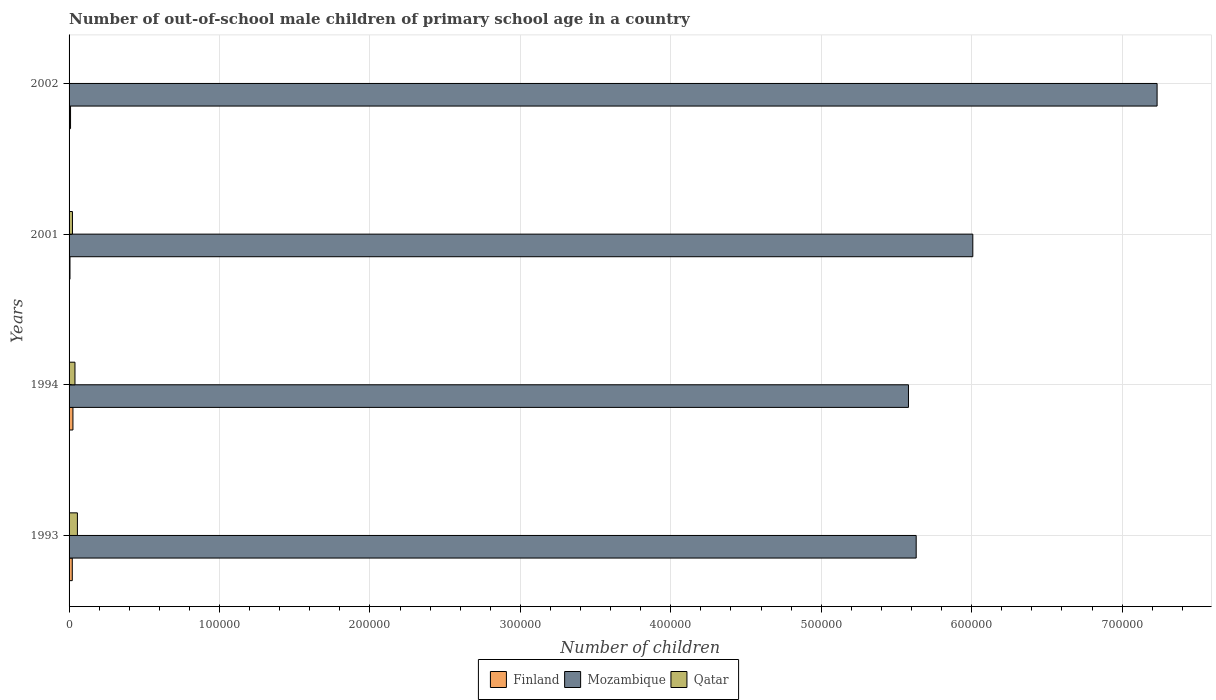Are the number of bars per tick equal to the number of legend labels?
Provide a succinct answer. Yes. Are the number of bars on each tick of the Y-axis equal?
Make the answer very short. Yes. How many bars are there on the 3rd tick from the bottom?
Offer a very short reply. 3. What is the label of the 3rd group of bars from the top?
Make the answer very short. 1994. In how many cases, is the number of bars for a given year not equal to the number of legend labels?
Offer a terse response. 0. What is the number of out-of-school male children in Mozambique in 1994?
Make the answer very short. 5.58e+05. Across all years, what is the maximum number of out-of-school male children in Mozambique?
Your response must be concise. 7.23e+05. Across all years, what is the minimum number of out-of-school male children in Finland?
Your answer should be compact. 611. In which year was the number of out-of-school male children in Finland minimum?
Your answer should be very brief. 2001. What is the total number of out-of-school male children in Mozambique in the graph?
Your response must be concise. 2.45e+06. What is the difference between the number of out-of-school male children in Qatar in 1994 and that in 2001?
Provide a short and direct response. 1671. What is the difference between the number of out-of-school male children in Mozambique in 1994 and the number of out-of-school male children in Finland in 1993?
Offer a very short reply. 5.56e+05. What is the average number of out-of-school male children in Mozambique per year?
Keep it short and to the point. 6.11e+05. In the year 2001, what is the difference between the number of out-of-school male children in Finland and number of out-of-school male children in Mozambique?
Your response must be concise. -6.00e+05. What is the ratio of the number of out-of-school male children in Mozambique in 1994 to that in 2002?
Provide a short and direct response. 0.77. What is the difference between the highest and the second highest number of out-of-school male children in Qatar?
Offer a terse response. 1618. What is the difference between the highest and the lowest number of out-of-school male children in Qatar?
Offer a very short reply. 5384. What does the 3rd bar from the top in 1994 represents?
Ensure brevity in your answer.  Finland. What does the 3rd bar from the bottom in 1993 represents?
Make the answer very short. Qatar. Is it the case that in every year, the sum of the number of out-of-school male children in Qatar and number of out-of-school male children in Mozambique is greater than the number of out-of-school male children in Finland?
Provide a short and direct response. Yes. How many bars are there?
Your answer should be very brief. 12. How many years are there in the graph?
Provide a short and direct response. 4. What is the difference between two consecutive major ticks on the X-axis?
Your answer should be compact. 1.00e+05. Does the graph contain grids?
Make the answer very short. Yes. Where does the legend appear in the graph?
Provide a short and direct response. Bottom center. What is the title of the graph?
Offer a very short reply. Number of out-of-school male children of primary school age in a country. Does "Kosovo" appear as one of the legend labels in the graph?
Offer a terse response. No. What is the label or title of the X-axis?
Your answer should be very brief. Number of children. What is the Number of children of Finland in 1993?
Offer a very short reply. 2135. What is the Number of children in Mozambique in 1993?
Provide a short and direct response. 5.63e+05. What is the Number of children of Qatar in 1993?
Provide a succinct answer. 5541. What is the Number of children in Finland in 1994?
Make the answer very short. 2569. What is the Number of children of Mozambique in 1994?
Your response must be concise. 5.58e+05. What is the Number of children of Qatar in 1994?
Your answer should be compact. 3923. What is the Number of children in Finland in 2001?
Keep it short and to the point. 611. What is the Number of children in Mozambique in 2001?
Your answer should be very brief. 6.01e+05. What is the Number of children of Qatar in 2001?
Your answer should be compact. 2252. What is the Number of children of Finland in 2002?
Your response must be concise. 977. What is the Number of children in Mozambique in 2002?
Offer a very short reply. 7.23e+05. What is the Number of children of Qatar in 2002?
Make the answer very short. 157. Across all years, what is the maximum Number of children of Finland?
Your response must be concise. 2569. Across all years, what is the maximum Number of children of Mozambique?
Give a very brief answer. 7.23e+05. Across all years, what is the maximum Number of children of Qatar?
Offer a very short reply. 5541. Across all years, what is the minimum Number of children in Finland?
Your answer should be very brief. 611. Across all years, what is the minimum Number of children of Mozambique?
Your answer should be compact. 5.58e+05. Across all years, what is the minimum Number of children of Qatar?
Provide a short and direct response. 157. What is the total Number of children in Finland in the graph?
Ensure brevity in your answer.  6292. What is the total Number of children of Mozambique in the graph?
Give a very brief answer. 2.45e+06. What is the total Number of children in Qatar in the graph?
Ensure brevity in your answer.  1.19e+04. What is the difference between the Number of children of Finland in 1993 and that in 1994?
Offer a very short reply. -434. What is the difference between the Number of children in Mozambique in 1993 and that in 1994?
Make the answer very short. 5134. What is the difference between the Number of children of Qatar in 1993 and that in 1994?
Offer a terse response. 1618. What is the difference between the Number of children in Finland in 1993 and that in 2001?
Keep it short and to the point. 1524. What is the difference between the Number of children in Mozambique in 1993 and that in 2001?
Keep it short and to the point. -3.76e+04. What is the difference between the Number of children in Qatar in 1993 and that in 2001?
Provide a short and direct response. 3289. What is the difference between the Number of children in Finland in 1993 and that in 2002?
Make the answer very short. 1158. What is the difference between the Number of children of Mozambique in 1993 and that in 2002?
Your answer should be compact. -1.60e+05. What is the difference between the Number of children of Qatar in 1993 and that in 2002?
Your answer should be very brief. 5384. What is the difference between the Number of children of Finland in 1994 and that in 2001?
Offer a terse response. 1958. What is the difference between the Number of children of Mozambique in 1994 and that in 2001?
Keep it short and to the point. -4.28e+04. What is the difference between the Number of children of Qatar in 1994 and that in 2001?
Give a very brief answer. 1671. What is the difference between the Number of children in Finland in 1994 and that in 2002?
Your answer should be very brief. 1592. What is the difference between the Number of children in Mozambique in 1994 and that in 2002?
Keep it short and to the point. -1.65e+05. What is the difference between the Number of children in Qatar in 1994 and that in 2002?
Your answer should be compact. 3766. What is the difference between the Number of children of Finland in 2001 and that in 2002?
Your response must be concise. -366. What is the difference between the Number of children in Mozambique in 2001 and that in 2002?
Keep it short and to the point. -1.22e+05. What is the difference between the Number of children in Qatar in 2001 and that in 2002?
Keep it short and to the point. 2095. What is the difference between the Number of children of Finland in 1993 and the Number of children of Mozambique in 1994?
Your response must be concise. -5.56e+05. What is the difference between the Number of children in Finland in 1993 and the Number of children in Qatar in 1994?
Provide a succinct answer. -1788. What is the difference between the Number of children in Mozambique in 1993 and the Number of children in Qatar in 1994?
Your answer should be very brief. 5.59e+05. What is the difference between the Number of children in Finland in 1993 and the Number of children in Mozambique in 2001?
Offer a very short reply. -5.99e+05. What is the difference between the Number of children in Finland in 1993 and the Number of children in Qatar in 2001?
Your response must be concise. -117. What is the difference between the Number of children of Mozambique in 1993 and the Number of children of Qatar in 2001?
Your answer should be compact. 5.61e+05. What is the difference between the Number of children in Finland in 1993 and the Number of children in Mozambique in 2002?
Your answer should be very brief. -7.21e+05. What is the difference between the Number of children in Finland in 1993 and the Number of children in Qatar in 2002?
Provide a succinct answer. 1978. What is the difference between the Number of children of Mozambique in 1993 and the Number of children of Qatar in 2002?
Provide a succinct answer. 5.63e+05. What is the difference between the Number of children of Finland in 1994 and the Number of children of Mozambique in 2001?
Offer a very short reply. -5.98e+05. What is the difference between the Number of children in Finland in 1994 and the Number of children in Qatar in 2001?
Give a very brief answer. 317. What is the difference between the Number of children in Mozambique in 1994 and the Number of children in Qatar in 2001?
Offer a very short reply. 5.56e+05. What is the difference between the Number of children in Finland in 1994 and the Number of children in Mozambique in 2002?
Offer a terse response. -7.21e+05. What is the difference between the Number of children in Finland in 1994 and the Number of children in Qatar in 2002?
Make the answer very short. 2412. What is the difference between the Number of children in Mozambique in 1994 and the Number of children in Qatar in 2002?
Make the answer very short. 5.58e+05. What is the difference between the Number of children in Finland in 2001 and the Number of children in Mozambique in 2002?
Offer a terse response. -7.23e+05. What is the difference between the Number of children in Finland in 2001 and the Number of children in Qatar in 2002?
Your answer should be compact. 454. What is the difference between the Number of children in Mozambique in 2001 and the Number of children in Qatar in 2002?
Make the answer very short. 6.01e+05. What is the average Number of children of Finland per year?
Ensure brevity in your answer.  1573. What is the average Number of children in Mozambique per year?
Give a very brief answer. 6.11e+05. What is the average Number of children in Qatar per year?
Give a very brief answer. 2968.25. In the year 1993, what is the difference between the Number of children of Finland and Number of children of Mozambique?
Give a very brief answer. -5.61e+05. In the year 1993, what is the difference between the Number of children of Finland and Number of children of Qatar?
Ensure brevity in your answer.  -3406. In the year 1993, what is the difference between the Number of children of Mozambique and Number of children of Qatar?
Ensure brevity in your answer.  5.58e+05. In the year 1994, what is the difference between the Number of children in Finland and Number of children in Mozambique?
Your response must be concise. -5.55e+05. In the year 1994, what is the difference between the Number of children of Finland and Number of children of Qatar?
Your answer should be compact. -1354. In the year 1994, what is the difference between the Number of children in Mozambique and Number of children in Qatar?
Give a very brief answer. 5.54e+05. In the year 2001, what is the difference between the Number of children in Finland and Number of children in Mozambique?
Provide a succinct answer. -6.00e+05. In the year 2001, what is the difference between the Number of children of Finland and Number of children of Qatar?
Provide a succinct answer. -1641. In the year 2001, what is the difference between the Number of children of Mozambique and Number of children of Qatar?
Your answer should be very brief. 5.99e+05. In the year 2002, what is the difference between the Number of children of Finland and Number of children of Mozambique?
Your response must be concise. -7.22e+05. In the year 2002, what is the difference between the Number of children of Finland and Number of children of Qatar?
Your response must be concise. 820. In the year 2002, what is the difference between the Number of children of Mozambique and Number of children of Qatar?
Keep it short and to the point. 7.23e+05. What is the ratio of the Number of children of Finland in 1993 to that in 1994?
Offer a very short reply. 0.83. What is the ratio of the Number of children of Mozambique in 1993 to that in 1994?
Your answer should be compact. 1.01. What is the ratio of the Number of children of Qatar in 1993 to that in 1994?
Make the answer very short. 1.41. What is the ratio of the Number of children in Finland in 1993 to that in 2001?
Keep it short and to the point. 3.49. What is the ratio of the Number of children of Mozambique in 1993 to that in 2001?
Ensure brevity in your answer.  0.94. What is the ratio of the Number of children in Qatar in 1993 to that in 2001?
Offer a terse response. 2.46. What is the ratio of the Number of children of Finland in 1993 to that in 2002?
Keep it short and to the point. 2.19. What is the ratio of the Number of children of Mozambique in 1993 to that in 2002?
Offer a very short reply. 0.78. What is the ratio of the Number of children of Qatar in 1993 to that in 2002?
Your response must be concise. 35.29. What is the ratio of the Number of children of Finland in 1994 to that in 2001?
Keep it short and to the point. 4.2. What is the ratio of the Number of children of Mozambique in 1994 to that in 2001?
Offer a very short reply. 0.93. What is the ratio of the Number of children of Qatar in 1994 to that in 2001?
Give a very brief answer. 1.74. What is the ratio of the Number of children of Finland in 1994 to that in 2002?
Provide a short and direct response. 2.63. What is the ratio of the Number of children in Mozambique in 1994 to that in 2002?
Your response must be concise. 0.77. What is the ratio of the Number of children of Qatar in 1994 to that in 2002?
Keep it short and to the point. 24.99. What is the ratio of the Number of children in Finland in 2001 to that in 2002?
Your answer should be very brief. 0.63. What is the ratio of the Number of children of Mozambique in 2001 to that in 2002?
Offer a very short reply. 0.83. What is the ratio of the Number of children in Qatar in 2001 to that in 2002?
Give a very brief answer. 14.34. What is the difference between the highest and the second highest Number of children of Finland?
Make the answer very short. 434. What is the difference between the highest and the second highest Number of children of Mozambique?
Offer a terse response. 1.22e+05. What is the difference between the highest and the second highest Number of children of Qatar?
Your response must be concise. 1618. What is the difference between the highest and the lowest Number of children of Finland?
Keep it short and to the point. 1958. What is the difference between the highest and the lowest Number of children in Mozambique?
Your answer should be very brief. 1.65e+05. What is the difference between the highest and the lowest Number of children in Qatar?
Make the answer very short. 5384. 